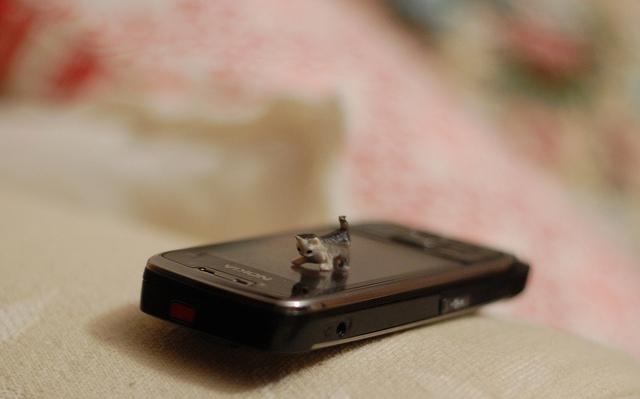Based on the phone size about what size is the cat sculpture?

Choices:
A) 5 inches
B) 1/2 inch
C) 1 foot
D) 24 inches 1/2 inch 